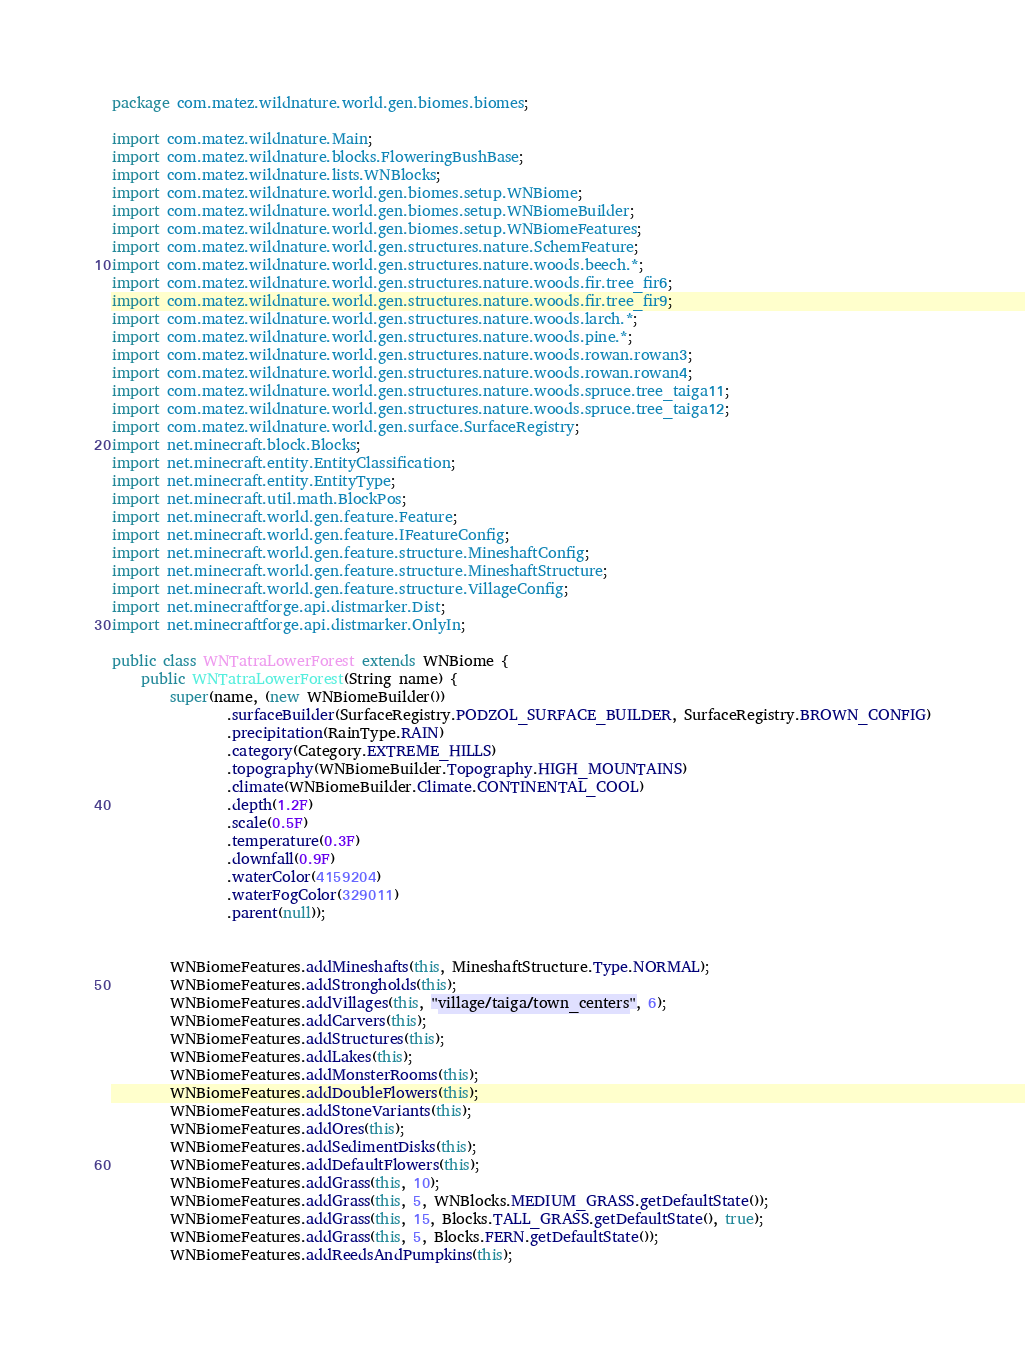<code> <loc_0><loc_0><loc_500><loc_500><_Java_>package com.matez.wildnature.world.gen.biomes.biomes;

import com.matez.wildnature.Main;
import com.matez.wildnature.blocks.FloweringBushBase;
import com.matez.wildnature.lists.WNBlocks;
import com.matez.wildnature.world.gen.biomes.setup.WNBiome;
import com.matez.wildnature.world.gen.biomes.setup.WNBiomeBuilder;
import com.matez.wildnature.world.gen.biomes.setup.WNBiomeFeatures;
import com.matez.wildnature.world.gen.structures.nature.SchemFeature;
import com.matez.wildnature.world.gen.structures.nature.woods.beech.*;
import com.matez.wildnature.world.gen.structures.nature.woods.fir.tree_fir6;
import com.matez.wildnature.world.gen.structures.nature.woods.fir.tree_fir9;
import com.matez.wildnature.world.gen.structures.nature.woods.larch.*;
import com.matez.wildnature.world.gen.structures.nature.woods.pine.*;
import com.matez.wildnature.world.gen.structures.nature.woods.rowan.rowan3;
import com.matez.wildnature.world.gen.structures.nature.woods.rowan.rowan4;
import com.matez.wildnature.world.gen.structures.nature.woods.spruce.tree_taiga11;
import com.matez.wildnature.world.gen.structures.nature.woods.spruce.tree_taiga12;
import com.matez.wildnature.world.gen.surface.SurfaceRegistry;
import net.minecraft.block.Blocks;
import net.minecraft.entity.EntityClassification;
import net.minecraft.entity.EntityType;
import net.minecraft.util.math.BlockPos;
import net.minecraft.world.gen.feature.Feature;
import net.minecraft.world.gen.feature.IFeatureConfig;
import net.minecraft.world.gen.feature.structure.MineshaftConfig;
import net.minecraft.world.gen.feature.structure.MineshaftStructure;
import net.minecraft.world.gen.feature.structure.VillageConfig;
import net.minecraftforge.api.distmarker.Dist;
import net.minecraftforge.api.distmarker.OnlyIn;

public class WNTatraLowerForest extends WNBiome {
    public WNTatraLowerForest(String name) {
        super(name, (new WNBiomeBuilder())
                .surfaceBuilder(SurfaceRegistry.PODZOL_SURFACE_BUILDER, SurfaceRegistry.BROWN_CONFIG)
                .precipitation(RainType.RAIN)
                .category(Category.EXTREME_HILLS)
                .topography(WNBiomeBuilder.Topography.HIGH_MOUNTAINS)
                .climate(WNBiomeBuilder.Climate.CONTINENTAL_COOL)
                .depth(1.2F)
                .scale(0.5F)
                .temperature(0.3F)
                .downfall(0.9F)
                .waterColor(4159204)
                .waterFogColor(329011)
                .parent(null));


        WNBiomeFeatures.addMineshafts(this, MineshaftStructure.Type.NORMAL);
        WNBiomeFeatures.addStrongholds(this);
        WNBiomeFeatures.addVillages(this, "village/taiga/town_centers", 6);
        WNBiomeFeatures.addCarvers(this);
        WNBiomeFeatures.addStructures(this);
        WNBiomeFeatures.addLakes(this);
        WNBiomeFeatures.addMonsterRooms(this);
        WNBiomeFeatures.addDoubleFlowers(this);
        WNBiomeFeatures.addStoneVariants(this);
        WNBiomeFeatures.addOres(this);
        WNBiomeFeatures.addSedimentDisks(this);
        WNBiomeFeatures.addDefaultFlowers(this);
        WNBiomeFeatures.addGrass(this, 10);
        WNBiomeFeatures.addGrass(this, 5, WNBlocks.MEDIUM_GRASS.getDefaultState());
        WNBiomeFeatures.addGrass(this, 15, Blocks.TALL_GRASS.getDefaultState(), true);
        WNBiomeFeatures.addGrass(this, 5, Blocks.FERN.getDefaultState());
        WNBiomeFeatures.addReedsAndPumpkins(this);</code> 